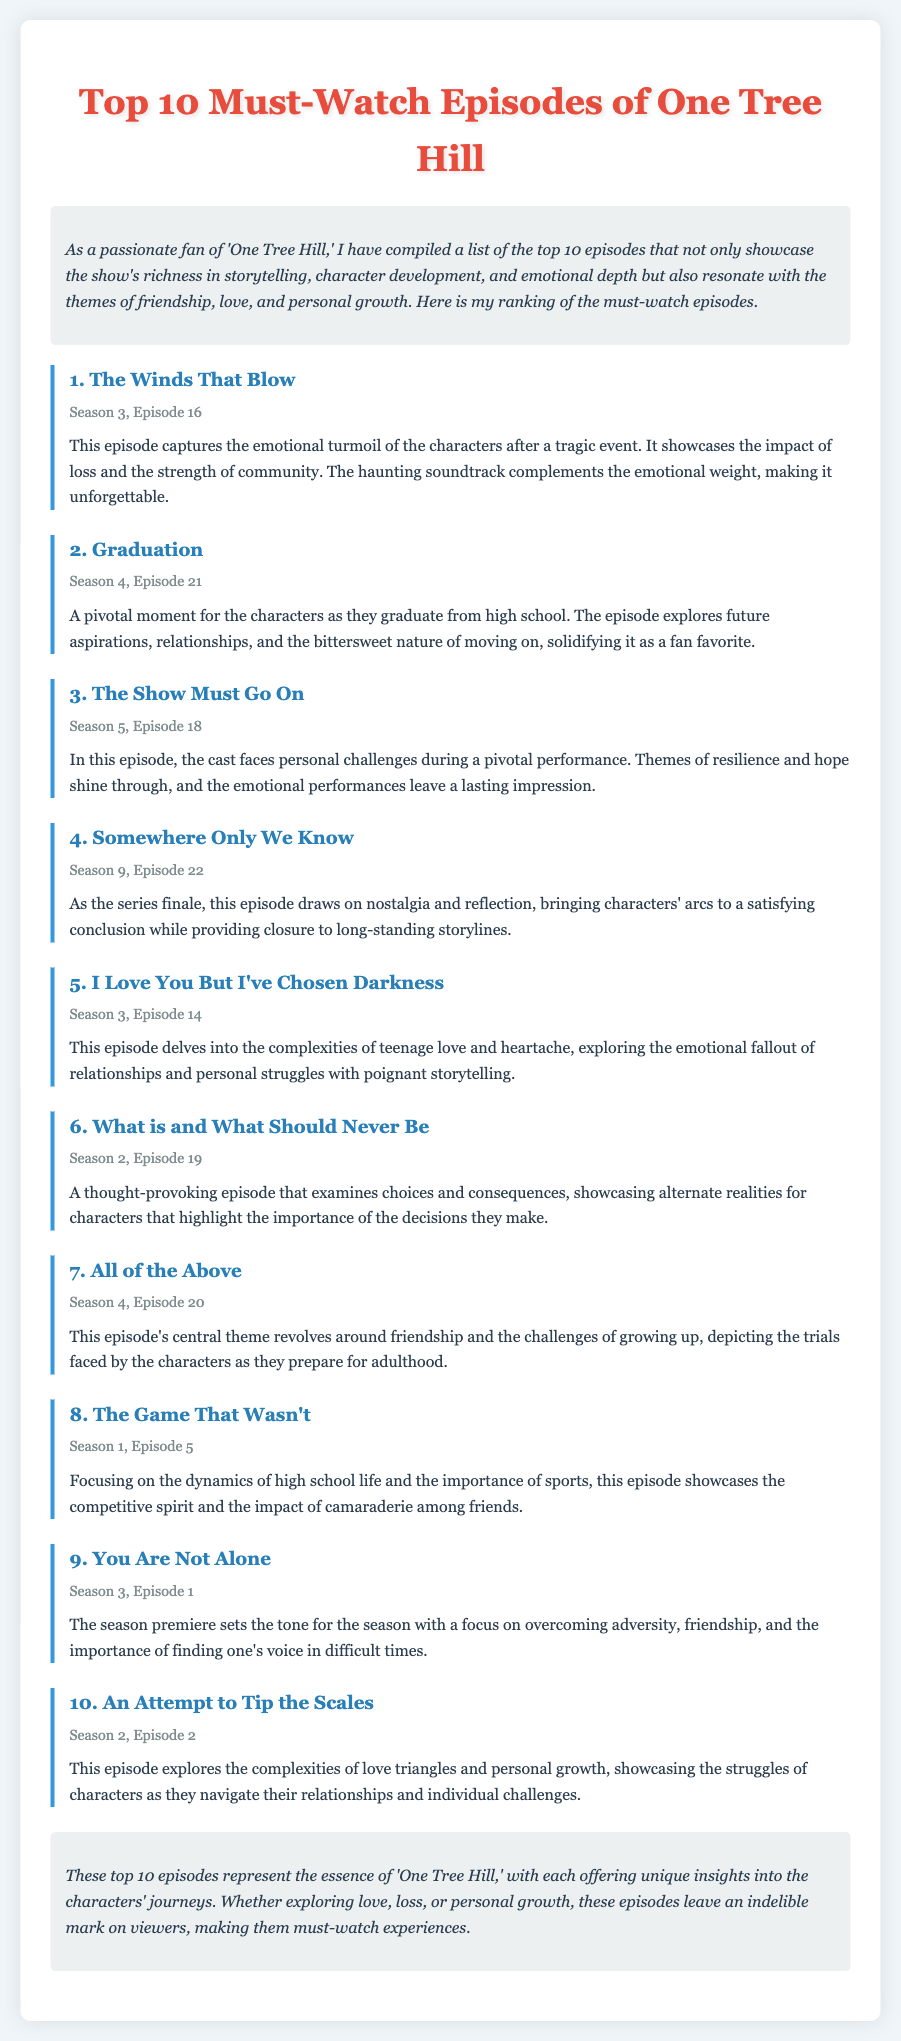What is the title of the document? The title is found in the header of the document and introduces the main topic.
Answer: Top 10 Must-Watch Episodes of One Tree Hill How many episodes are ranked in the list? The total number of episodes mentioned in the document is counted from the rankings provided.
Answer: 10 What is the title of the first episode listed? The first episode is identified by its position in the ranking and its corresponding title.
Answer: The Winds That Blow Which season and episode number is "Graduation"? The season and episode number are specified in the information section of that particular episode in the list.
Answer: Season 4, Episode 21 What is a central theme of "All of the Above"? The theme is described in the episode overview, highlighting its main focus.
Answer: Friendship and the challenges of growing up Which episode serves as the series finale? The series finale is indicated clearly at its position within the rankings of episodes.
Answer: Somewhere Only We Know What emotional aspect does "You Are Not Alone" focus on? This aspect is referenced in the descriptive text of the episode's overview.
Answer: Overcoming adversity What type of struggles are showcased in "An Attempt to Tip the Scales"? The struggle type is mentioned in the episode description, focusing on character relationships.
Answer: Love triangles and personal growth 